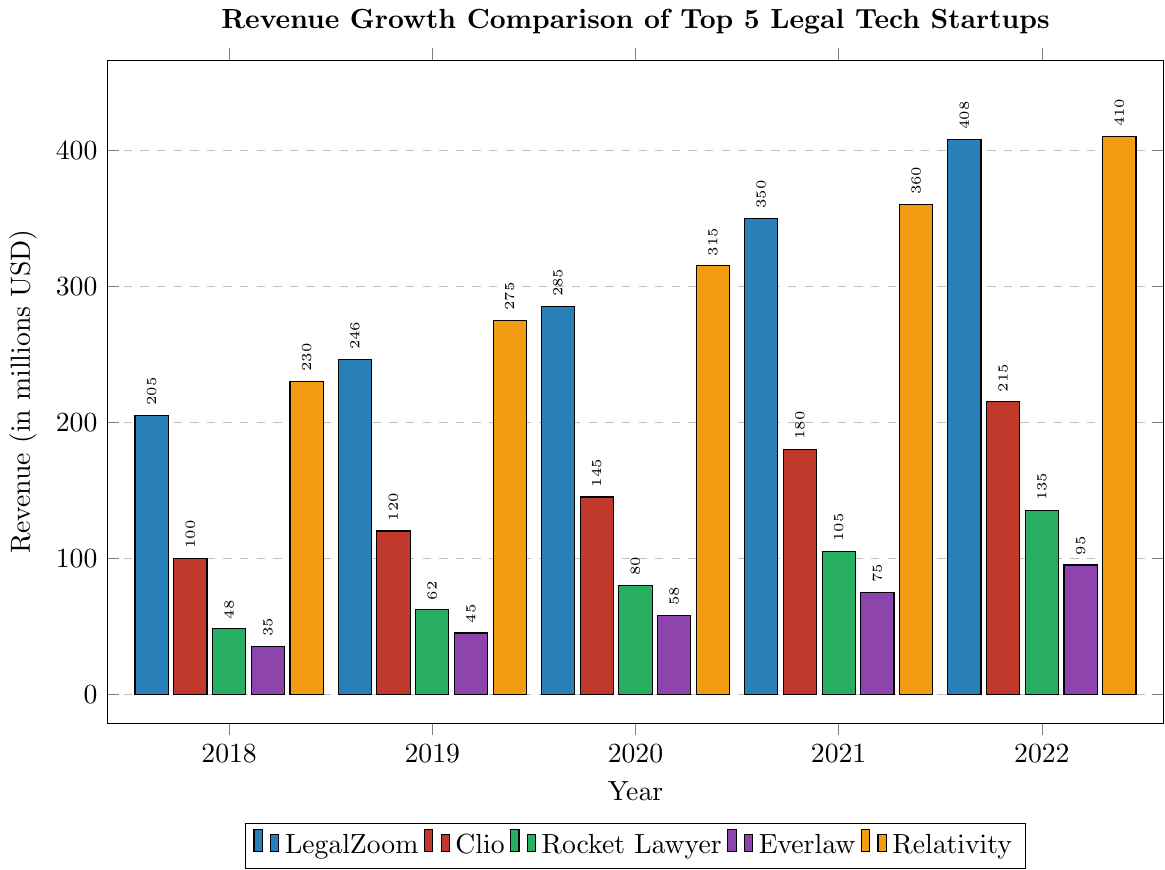What was the overall revenue growth for LegalZoom from 2018 to 2022? To calculate the overall revenue growth, subtract the initial revenue of 2018 (205 million) from the final revenue of 2022 (408 million) and then find the difference (408 - 205 = 203 million).
Answer: 203 million By how much did Relativity's revenue grow between 2019 and 2021? To find the revenue growth, subtract the revenue for 2019 (275 million) from the revenue for 2021 (360 million) (360 - 275 = 85 million).
Answer: 85 million Which company had the highest revenue in 2020, and what was that revenue? By visually comparing the heights of the bars for each company in 2020, the tallest bar corresponds to Relativity with a revenue of 315 million.
Answer: Relativity, 315 million Compare the revenue of Rocket Lawyer and Everlaw in 2018. Which company had higher revenue, and by how much? Rocket Lawyer's revenue in 2018 was 48 million, while Everlaw's was 35 million. To find the difference, subtract Everlaw's revenue from Rocket Lawyer's (48 - 35 = 13 million).
Answer: Rocket Lawyer, 13 million What is the average annual revenue for Clio from 2018 to 2022? To calculate the average, sum up Clio's annual revenues from 2018 to 2022 (100 + 120 + 145 + 180 + 215 = 760 million) and divide by the number of years (760 / 5 = 152 million).
Answer: 152 million Which company had the least revenue growth from 2018 to 2022, and what was the growth? To find the least revenue growth, subtract the initial revenue of 2018 from the final revenue of 2022 for each company: LegalZoom (408 - 205), Clio (215 - 100), Rocket Lawyer (135 - 48), Everlaw (95 - 35), Relativity (410 - 230); Everlaw had the smallest growth of (95 - 35 = 60 million).
Answer: Everlaw, 60 million Did any company's revenue ever decrease from one year to the next over the 5-year period? By visually examining the bar heights for each company year over year, none of the bars decrease in height.
Answer: No In which year did LegalZoom see the largest year-over-year revenue growth, and how much was that growth? To determine the largest year-over-year growth for LegalZoom, compare the yearly differences: 2019-2018 (246-205=41), 2020-2019 (285-246=39), 2021-2020 (350-285=65), 2022-2021 (408-350=58). The largest growth was from 2020 to 2021 with 65 million.
Answer: 2021, 65 million What was Everlaw's total revenue over the 5-year period? Add Everlaw's annual revenues from 2018 to 2022 (35 + 45 + 58 + 75 + 95 = 308 million).
Answer: 308 million Which company showed consistent growth every year without experiencing a plateau, and how is this visually confirmed? Visually, all companies demonstrate consistent growth with no plateaus or declines in the bar heights every year from 2018 to 2022.
Answer: All companies 